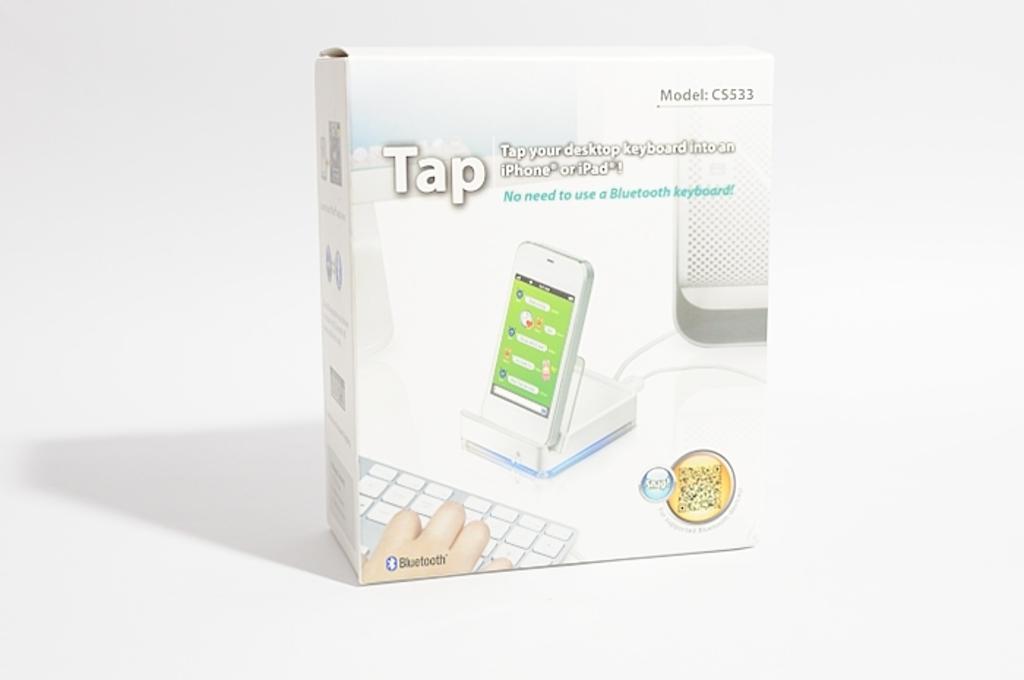What is the company name that makes this product?
Provide a short and direct response. Tap. What model of phone is this?
Your answer should be compact. Cs533. 